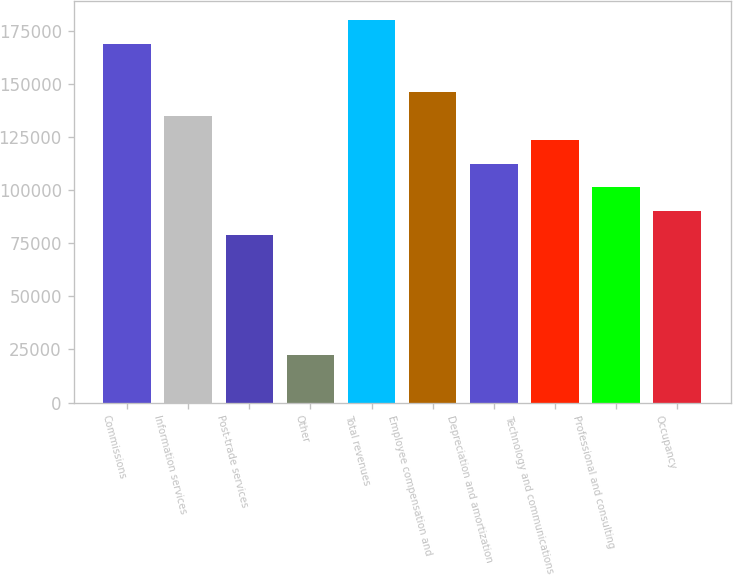<chart> <loc_0><loc_0><loc_500><loc_500><bar_chart><fcel>Commissions<fcel>Information services<fcel>Post-trade services<fcel>Other<fcel>Total revenues<fcel>Employee compensation and<fcel>Depreciation and amortization<fcel>Technology and communications<fcel>Professional and consulting<fcel>Occupancy<nl><fcel>168665<fcel>134933<fcel>78711.2<fcel>22489.8<fcel>179910<fcel>146177<fcel>112444<fcel>123688<fcel>101200<fcel>89955.4<nl></chart> 